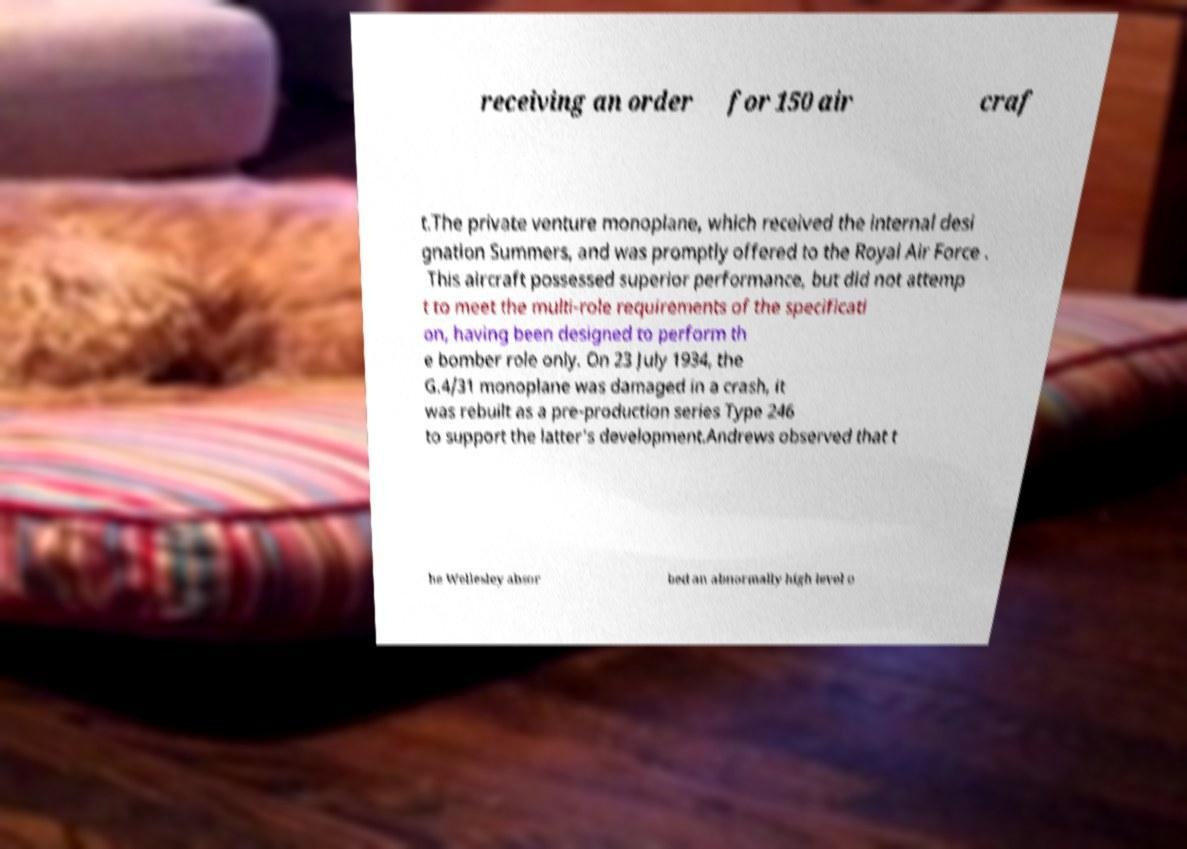Can you read and provide the text displayed in the image?This photo seems to have some interesting text. Can you extract and type it out for me? receiving an order for 150 air craf t.The private venture monoplane, which received the internal desi gnation Summers, and was promptly offered to the Royal Air Force . This aircraft possessed superior performance, but did not attemp t to meet the multi-role requirements of the specificati on, having been designed to perform th e bomber role only. On 23 July 1934, the G.4/31 monoplane was damaged in a crash, it was rebuilt as a pre-production series Type 246 to support the latter's development.Andrews observed that t he Wellesley absor bed an abnormally high level o 